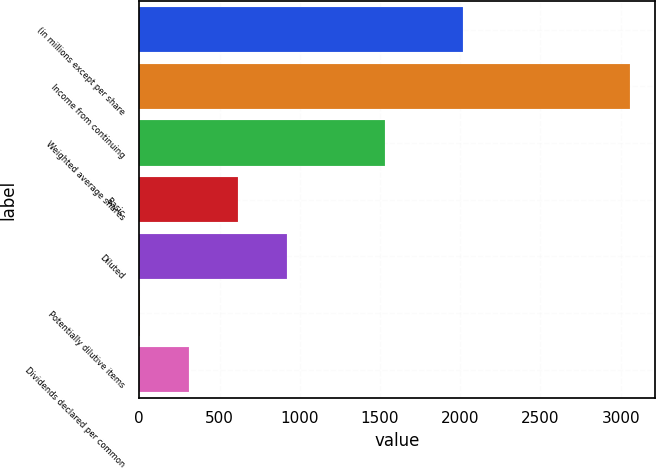Convert chart to OTSL. <chart><loc_0><loc_0><loc_500><loc_500><bar_chart><fcel>(in millions except per share<fcel>Income from continuing<fcel>Weighted average shares<fcel>Basic<fcel>Diluted<fcel>Potentially dilutive items<fcel>Dividends declared per common<nl><fcel>2017<fcel>3059<fcel>1530.5<fcel>613.4<fcel>919.1<fcel>2<fcel>307.7<nl></chart> 